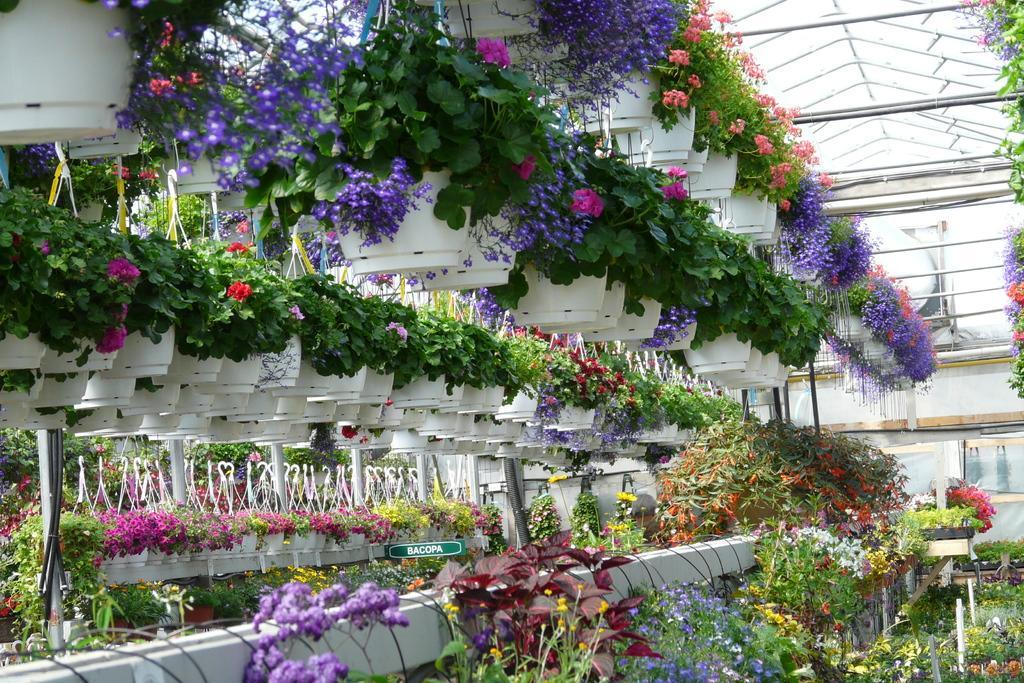Could you give a brief overview of what you see in this image? There are some artificial plants with some flowers in the pots as we can see in the middle of this image. 